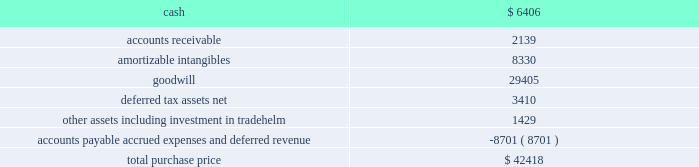Table of contents marketaxess holdings inc .
Notes to consolidated financial statements 2014 ( continued ) of this standard had no material effect on the company 2019s consolidated statements of financial condition and consolidated statements of operations .
Reclassifications certain reclassifications have been made to the prior years 2019 financial statements in order to conform to the current year presentation .
Such reclassifications had no effect on previously reported net income .
On march 5 , 2008 , the company acquired all of the outstanding capital stock of greenline financial technologies , inc .
( 201cgreenline 201d ) , an illinois-based provider of integration , testing and management solutions for fix-related products and services designed to optimize electronic trading of fixed-income , equity and other exchange-based products , and approximately ten percent of the outstanding capital stock of tradehelm , inc. , a delaware corporation that was spun-out from greenline immediately prior to the acquisition .
The acquisition of greenline broadens the range of technology services that the company offers to institutional financial markets , provides an expansion of the company 2019s client base , including global exchanges and hedge funds , and further diversifies the company 2019s revenues beyond the core electronic credit trading products .
The results of operations of greenline are included in the consolidated financial statements from the date of the acquisition .
The aggregate consideration for the greenline acquisition was $ 41.1 million , comprised of $ 34.7 million in cash , 725923 shares of common stock valued at $ 5.8 million and $ 0.6 million of acquisition-related costs .
In addition , the sellers were eligible to receive up to an aggregate of $ 3.0 million in cash , subject to greenline attaining certain earn- out targets in 2008 and 2009 .
A total of $ 1.4 million was paid to the sellers in 2009 based on the 2008 earn-out target , bringing the aggregate consideration to $ 42.4 million .
The 2009 earn-out target was not met .
A total of $ 2.0 million of the purchase price , which had been deposited into escrow accounts to satisfy potential indemnity claims , was distributed to the sellers in march 2009 .
The shares of common stock issued to each selling shareholder of greenline were released in two equal installments on december 20 , 2008 and december 20 , 2009 , respectively .
The value ascribed to the shares was discounted from the market value to reflect the non-marketability of such shares during the restriction period .
The purchase price allocation is as follows ( in thousands ) : the amortizable intangibles include $ 3.2 million of acquired technology , $ 3.3 million of customer relationships , $ 1.3 million of non-competition agreements and $ 0.5 million of tradenames .
Useful lives of ten years and five years have been assigned to the customer relationships intangible and all other amortizable intangibles , respectively .
The identifiable intangible assets and goodwill are not deductible for tax purposes .
The following unaudited pro forma consolidated financial information reflects the results of operations of the company for the years ended december 31 , 2008 and 2007 , as if the acquisition of greenline had occurred as of the beginning of the period presented , after giving effect to certain purchase accounting adjustments .
These pro forma results are not necessarily indicative of what the company 2019s operating results would have been had the acquisition actually taken place as of the beginning of the earliest period presented .
The pro forma financial information 3 .
Acquisitions .

Of the aggregate consideration for the greenline acquisition , what percentage was in cash? 
Computations: (6406 / 42418)
Answer: 0.15102. 